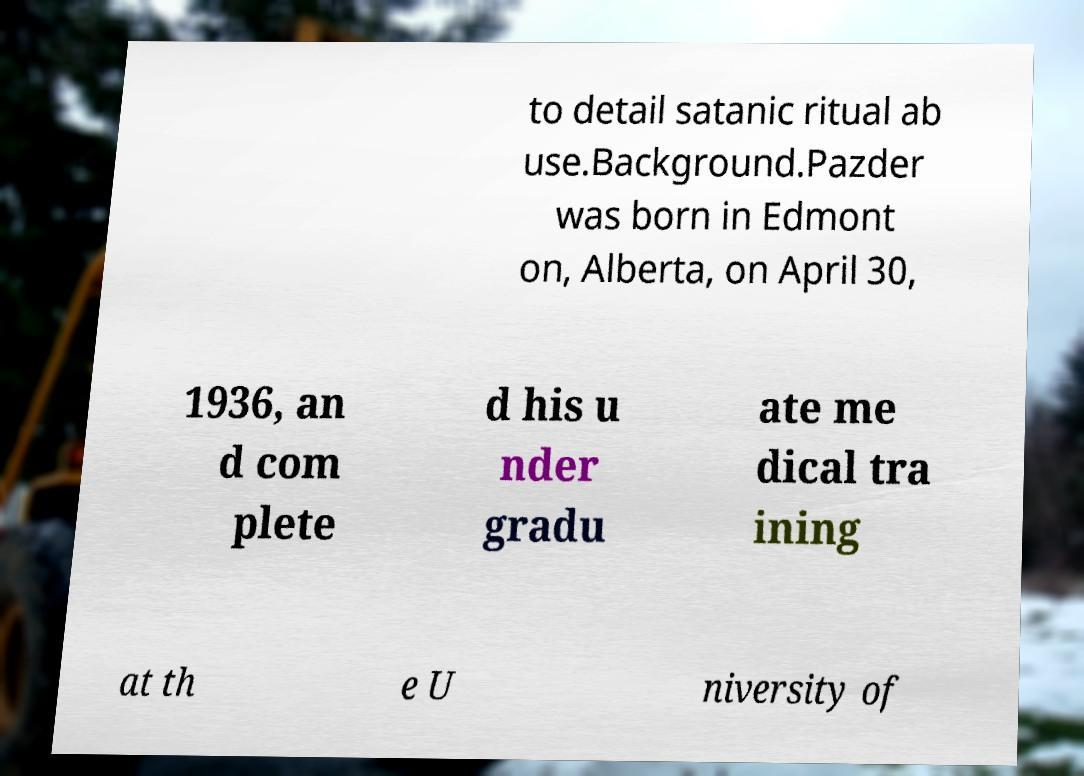Can you accurately transcribe the text from the provided image for me? to detail satanic ritual ab use.Background.Pazder was born in Edmont on, Alberta, on April 30, 1936, an d com plete d his u nder gradu ate me dical tra ining at th e U niversity of 